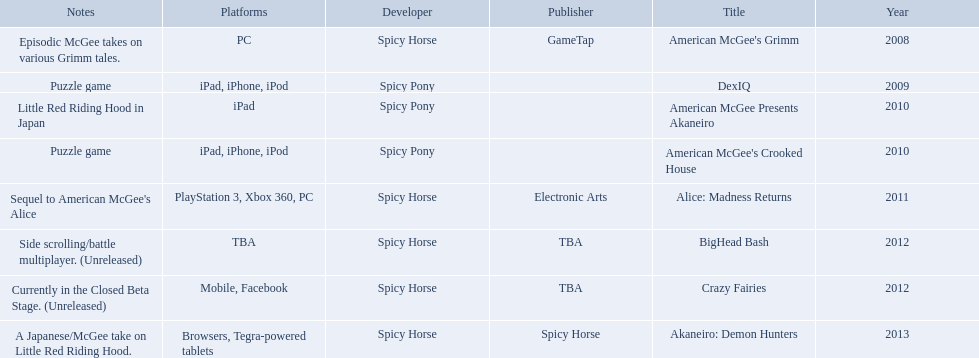Which spicy horse titles are shown? American McGee's Grimm, DexIQ, American McGee Presents Akaneiro, American McGee's Crooked House, Alice: Madness Returns, BigHead Bash, Crazy Fairies, Akaneiro: Demon Hunters. Of those, which are for the ipad? DexIQ, American McGee Presents Akaneiro, American McGee's Crooked House. Which of those are not for the iphone or ipod? American McGee Presents Akaneiro. What are all the titles of games published? American McGee's Grimm, DexIQ, American McGee Presents Akaneiro, American McGee's Crooked House, Alice: Madness Returns, BigHead Bash, Crazy Fairies, Akaneiro: Demon Hunters. What are all the names of the publishers? GameTap, , , , Electronic Arts, TBA, TBA, Spicy Horse. What is the published game title that corresponds to electronic arts? Alice: Madness Returns. 